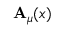Convert formula to latex. <formula><loc_0><loc_0><loc_500><loc_500>A _ { \mu } ( x )</formula> 